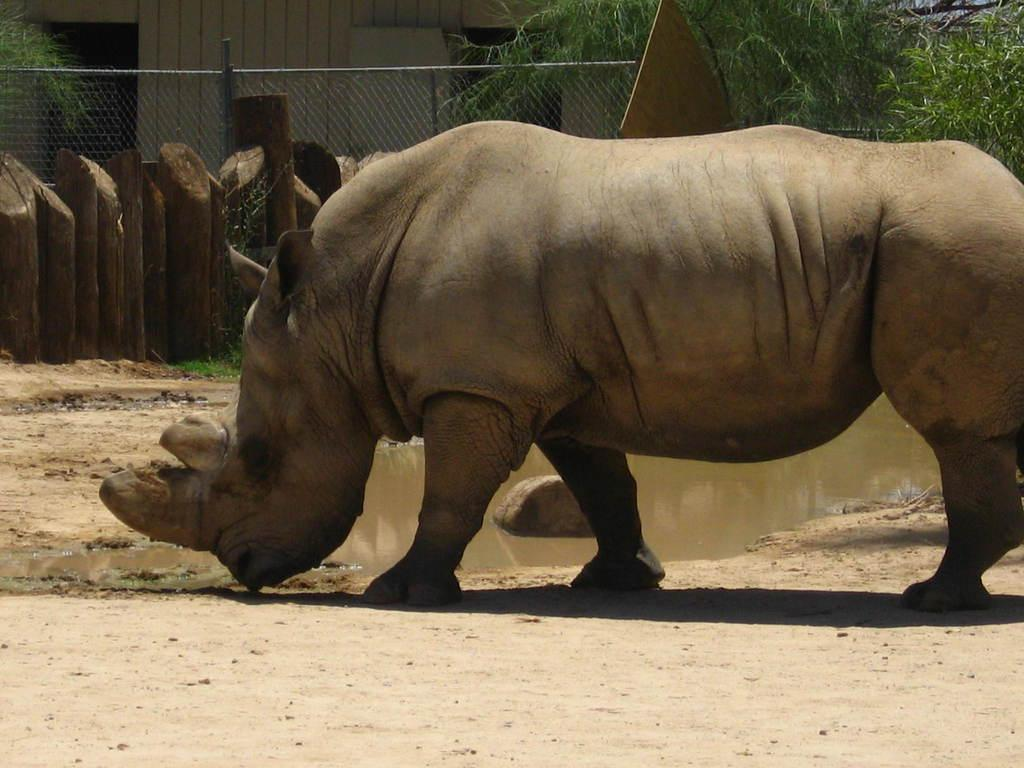What animal is the main subject of the image? There is a hippopotamus in the image. What can be seen beneath the hippopotamus? The ground is visible in the image. What is the hippopotamus standing in? There is water in the image. What is visible in the background of the image? There is fencing and leaves in the background of the image. What type of dinosaurs can be seen in the image? There are no dinosaurs or any type of yarn present in the image. 